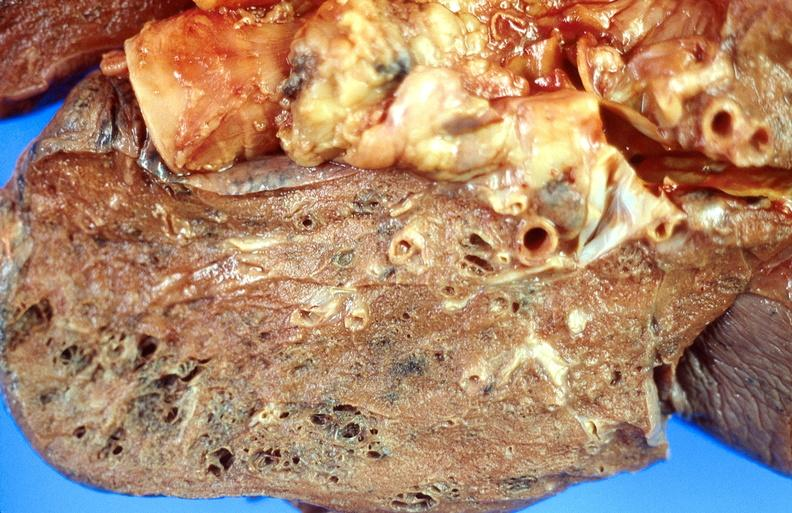s respiratory present?
Answer the question using a single word or phrase. Yes 